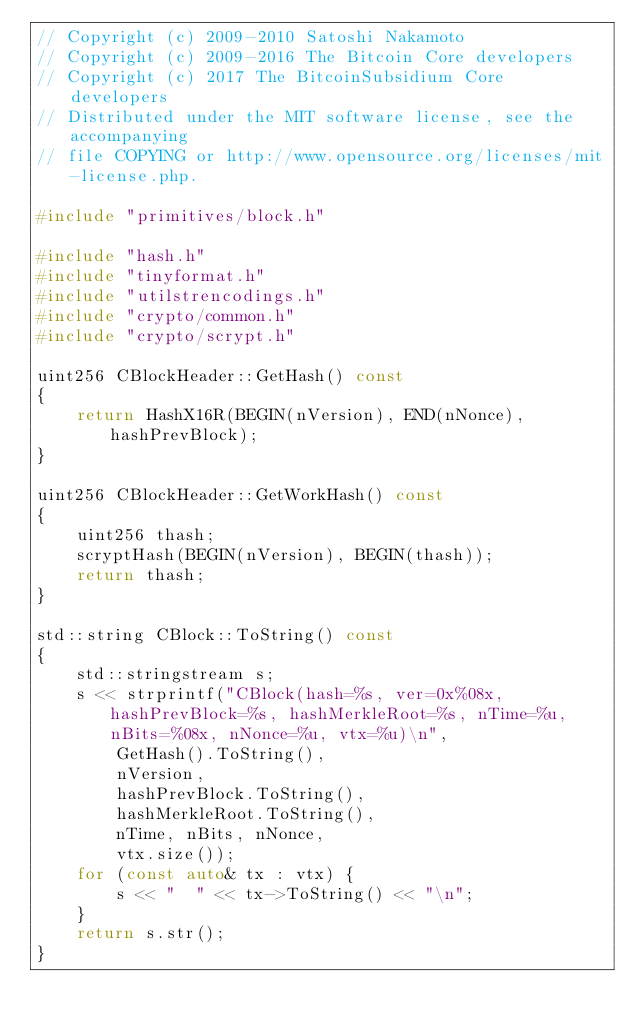Convert code to text. <code><loc_0><loc_0><loc_500><loc_500><_C++_>// Copyright (c) 2009-2010 Satoshi Nakamoto
// Copyright (c) 2009-2016 The Bitcoin Core developers
// Copyright (c) 2017 The BitcoinSubsidium Core developers
// Distributed under the MIT software license, see the accompanying
// file COPYING or http://www.opensource.org/licenses/mit-license.php.

#include "primitives/block.h"

#include "hash.h"
#include "tinyformat.h"
#include "utilstrencodings.h"
#include "crypto/common.h"
#include "crypto/scrypt.h"

uint256 CBlockHeader::GetHash() const
{
    return HashX16R(BEGIN(nVersion), END(nNonce), hashPrevBlock);
}

uint256 CBlockHeader::GetWorkHash() const
{
    uint256 thash;
    scryptHash(BEGIN(nVersion), BEGIN(thash));
    return thash;
}

std::string CBlock::ToString() const
{
    std::stringstream s;
    s << strprintf("CBlock(hash=%s, ver=0x%08x, hashPrevBlock=%s, hashMerkleRoot=%s, nTime=%u, nBits=%08x, nNonce=%u, vtx=%u)\n",
        GetHash().ToString(),
        nVersion,
        hashPrevBlock.ToString(),
        hashMerkleRoot.ToString(),
        nTime, nBits, nNonce,
        vtx.size());
    for (const auto& tx : vtx) {
        s << "  " << tx->ToString() << "\n";
    }
    return s.str();
}
</code> 